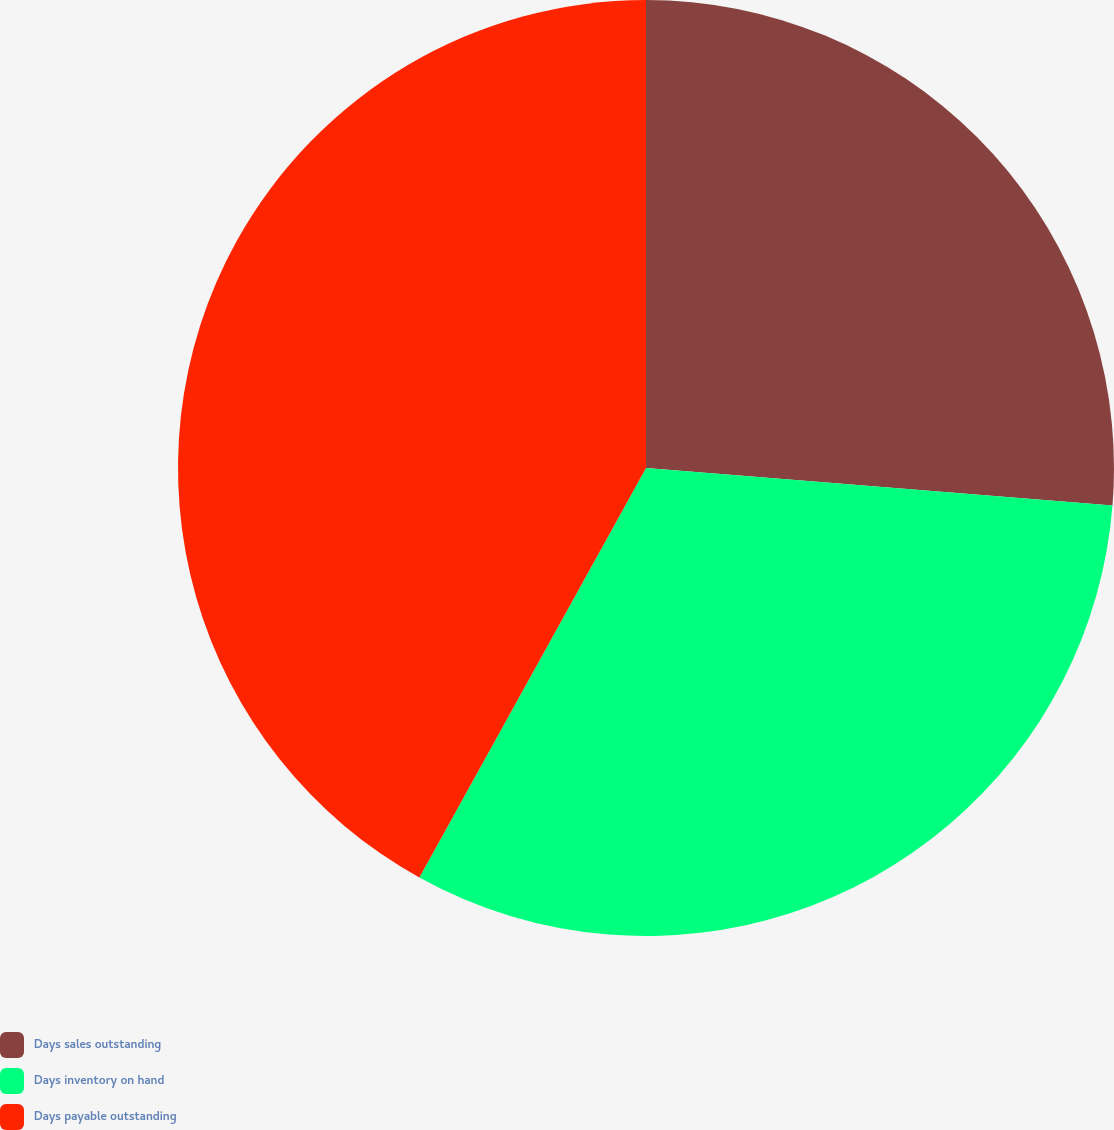<chart> <loc_0><loc_0><loc_500><loc_500><pie_chart><fcel>Days sales outstanding<fcel>Days inventory on hand<fcel>Days payable outstanding<nl><fcel>26.27%<fcel>31.77%<fcel>41.95%<nl></chart> 